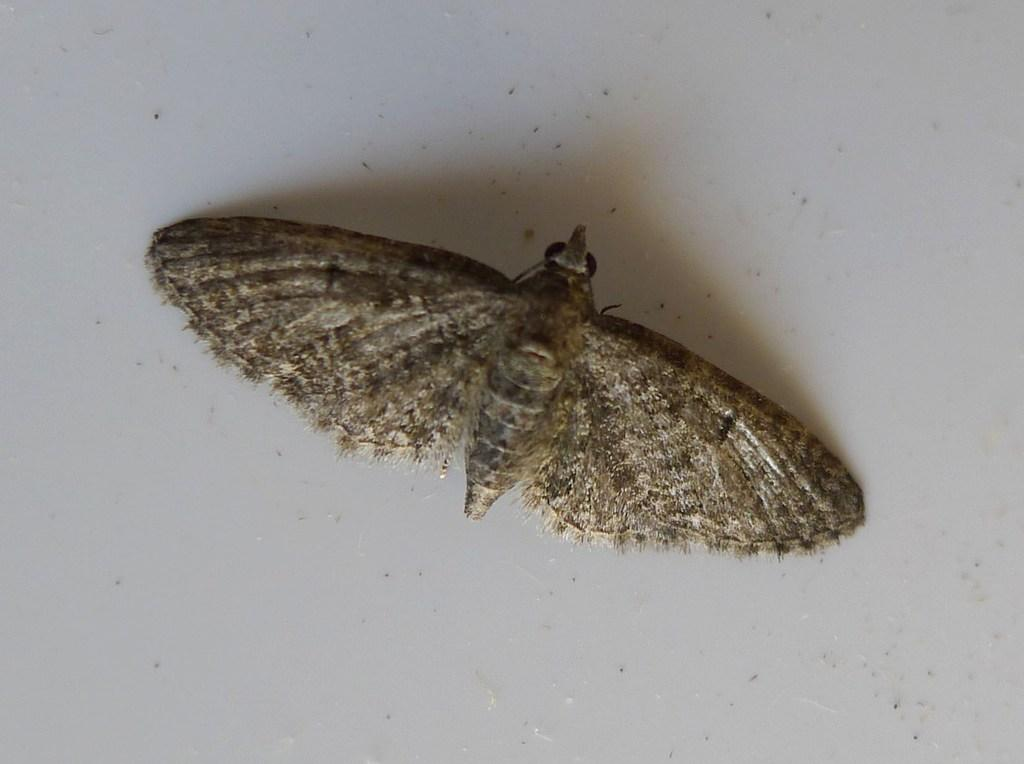What type of creature can be seen in the image? There is an insect in the image. Where is the insect located in the image? The insect is on the surface. What type of shock can be seen affecting the insect in the image? There is no shock present in the image; it only features an insect on the surface. What type of tongue can be seen in the image? There is no tongue present in the image. What type of stamp can be seen in the image? There is no stamp present in the image. 